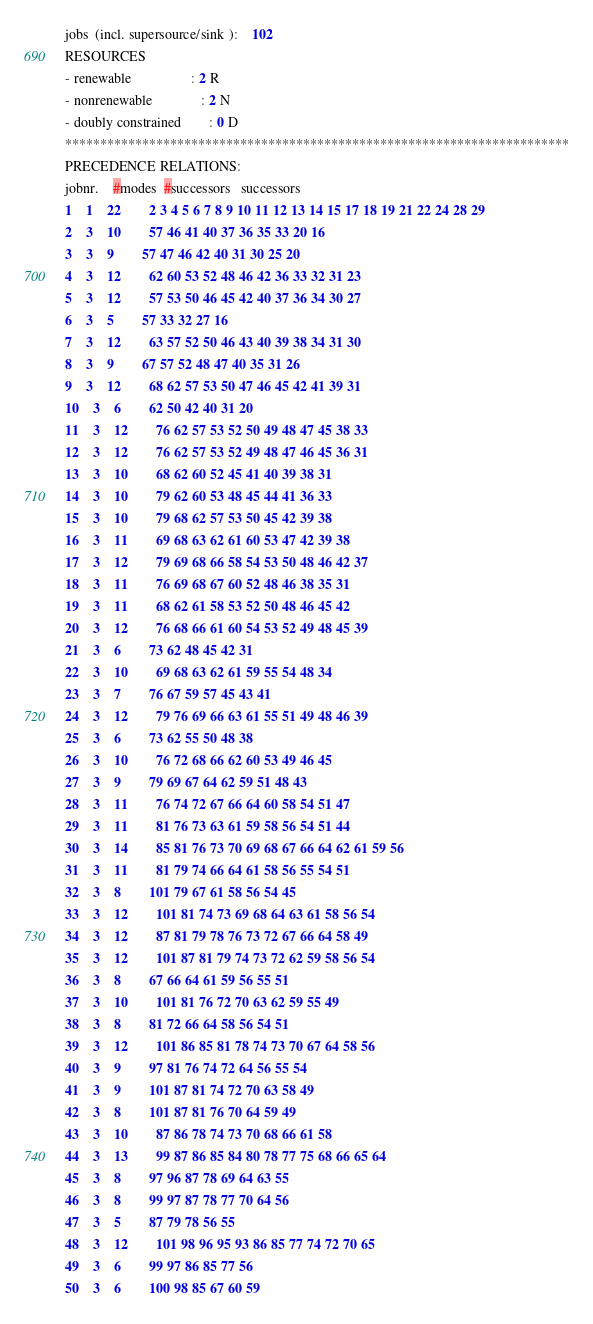<code> <loc_0><loc_0><loc_500><loc_500><_ObjectiveC_>jobs  (incl. supersource/sink ):	102
RESOURCES
- renewable                 : 2 R
- nonrenewable              : 2 N
- doubly constrained        : 0 D
************************************************************************
PRECEDENCE RELATIONS:
jobnr.    #modes  #successors   successors
1	1	22		2 3 4 5 6 7 8 9 10 11 12 13 14 15 17 18 19 21 22 24 28 29 
2	3	10		57 46 41 40 37 36 35 33 20 16 
3	3	9		57 47 46 42 40 31 30 25 20 
4	3	12		62 60 53 52 48 46 42 36 33 32 31 23 
5	3	12		57 53 50 46 45 42 40 37 36 34 30 27 
6	3	5		57 33 32 27 16 
7	3	12		63 57 52 50 46 43 40 39 38 34 31 30 
8	3	9		67 57 52 48 47 40 35 31 26 
9	3	12		68 62 57 53 50 47 46 45 42 41 39 31 
10	3	6		62 50 42 40 31 20 
11	3	12		76 62 57 53 52 50 49 48 47 45 38 33 
12	3	12		76 62 57 53 52 49 48 47 46 45 36 31 
13	3	10		68 62 60 52 45 41 40 39 38 31 
14	3	10		79 62 60 53 48 45 44 41 36 33 
15	3	10		79 68 62 57 53 50 45 42 39 38 
16	3	11		69 68 63 62 61 60 53 47 42 39 38 
17	3	12		79 69 68 66 58 54 53 50 48 46 42 37 
18	3	11		76 69 68 67 60 52 48 46 38 35 31 
19	3	11		68 62 61 58 53 52 50 48 46 45 42 
20	3	12		76 68 66 61 60 54 53 52 49 48 45 39 
21	3	6		73 62 48 45 42 31 
22	3	10		69 68 63 62 61 59 55 54 48 34 
23	3	7		76 67 59 57 45 43 41 
24	3	12		79 76 69 66 63 61 55 51 49 48 46 39 
25	3	6		73 62 55 50 48 38 
26	3	10		76 72 68 66 62 60 53 49 46 45 
27	3	9		79 69 67 64 62 59 51 48 43 
28	3	11		76 74 72 67 66 64 60 58 54 51 47 
29	3	11		81 76 73 63 61 59 58 56 54 51 44 
30	3	14		85 81 76 73 70 69 68 67 66 64 62 61 59 56 
31	3	11		81 79 74 66 64 61 58 56 55 54 51 
32	3	8		101 79 67 61 58 56 54 45 
33	3	12		101 81 74 73 69 68 64 63 61 58 56 54 
34	3	12		87 81 79 78 76 73 72 67 66 64 58 49 
35	3	12		101 87 81 79 74 73 72 62 59 58 56 54 
36	3	8		67 66 64 61 59 56 55 51 
37	3	10		101 81 76 72 70 63 62 59 55 49 
38	3	8		81 72 66 64 58 56 54 51 
39	3	12		101 86 85 81 78 74 73 70 67 64 58 56 
40	3	9		97 81 76 74 72 64 56 55 54 
41	3	9		101 87 81 74 72 70 63 58 49 
42	3	8		101 87 81 76 70 64 59 49 
43	3	10		87 86 78 74 73 70 68 66 61 58 
44	3	13		99 87 86 85 84 80 78 77 75 68 66 65 64 
45	3	8		97 96 87 78 69 64 63 55 
46	3	8		99 97 87 78 77 70 64 56 
47	3	5		87 79 78 56 55 
48	3	12		101 98 96 95 93 86 85 77 74 72 70 65 
49	3	6		99 97 86 85 77 56 
50	3	6		100 98 85 67 60 59 </code> 